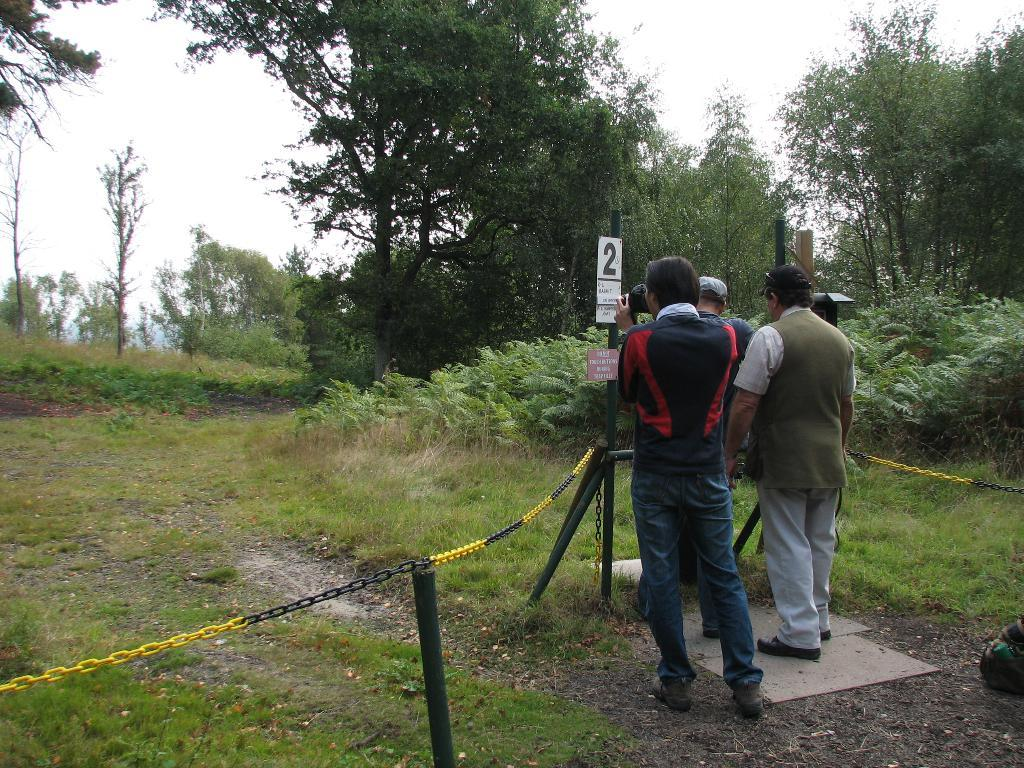What is happening in the image? There are people standing in the image. What are the people wearing? The people are wearing clothes and shoes. Can you describe any accessories the people are wearing? Two people are wearing caps. What objects can be seen in the image? There is a camera, a chain, and a pole in the image. What type of natural environment is visible in the image? There is grass, a plant, trees, and the sky in the image. How would you describe the sky in the image? The sky is white in the image. What letter is being used to cover the camera in the image? There is no letter being used to cover the camera in the image. How many legs does the plant have in the image? The plant in the image does not have legs; it is a plant, not an animal. 